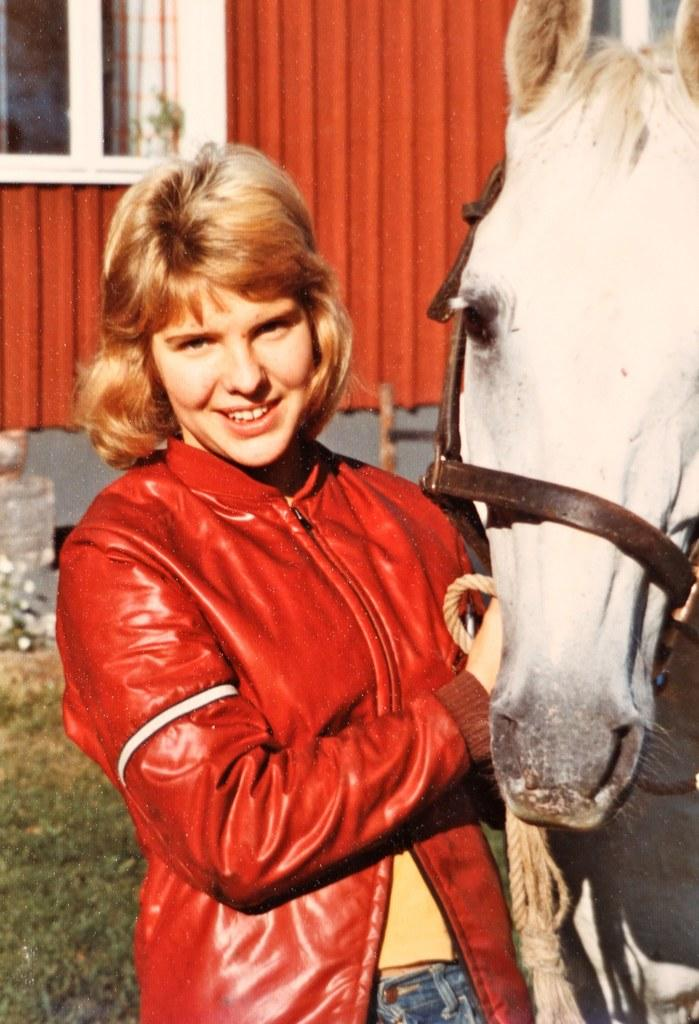Who or what is present in the image? There is a person in the image. What is the person doing in the image? The person is standing. What other living creature is in the image? There is a horse in the image. Where is the horse located in relation to the person? The horse is beside the person. What type of straw is being used by the person in the image? There is no straw present in the image. 